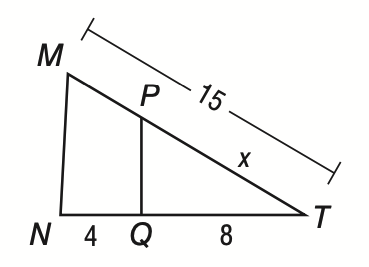Answer the mathemtical geometry problem and directly provide the correct option letter.
Question: If M N \parallel P Q, use a proportion to find the value of x.
Choices: A: 5 B: 8 C: 10 D: 12 C 